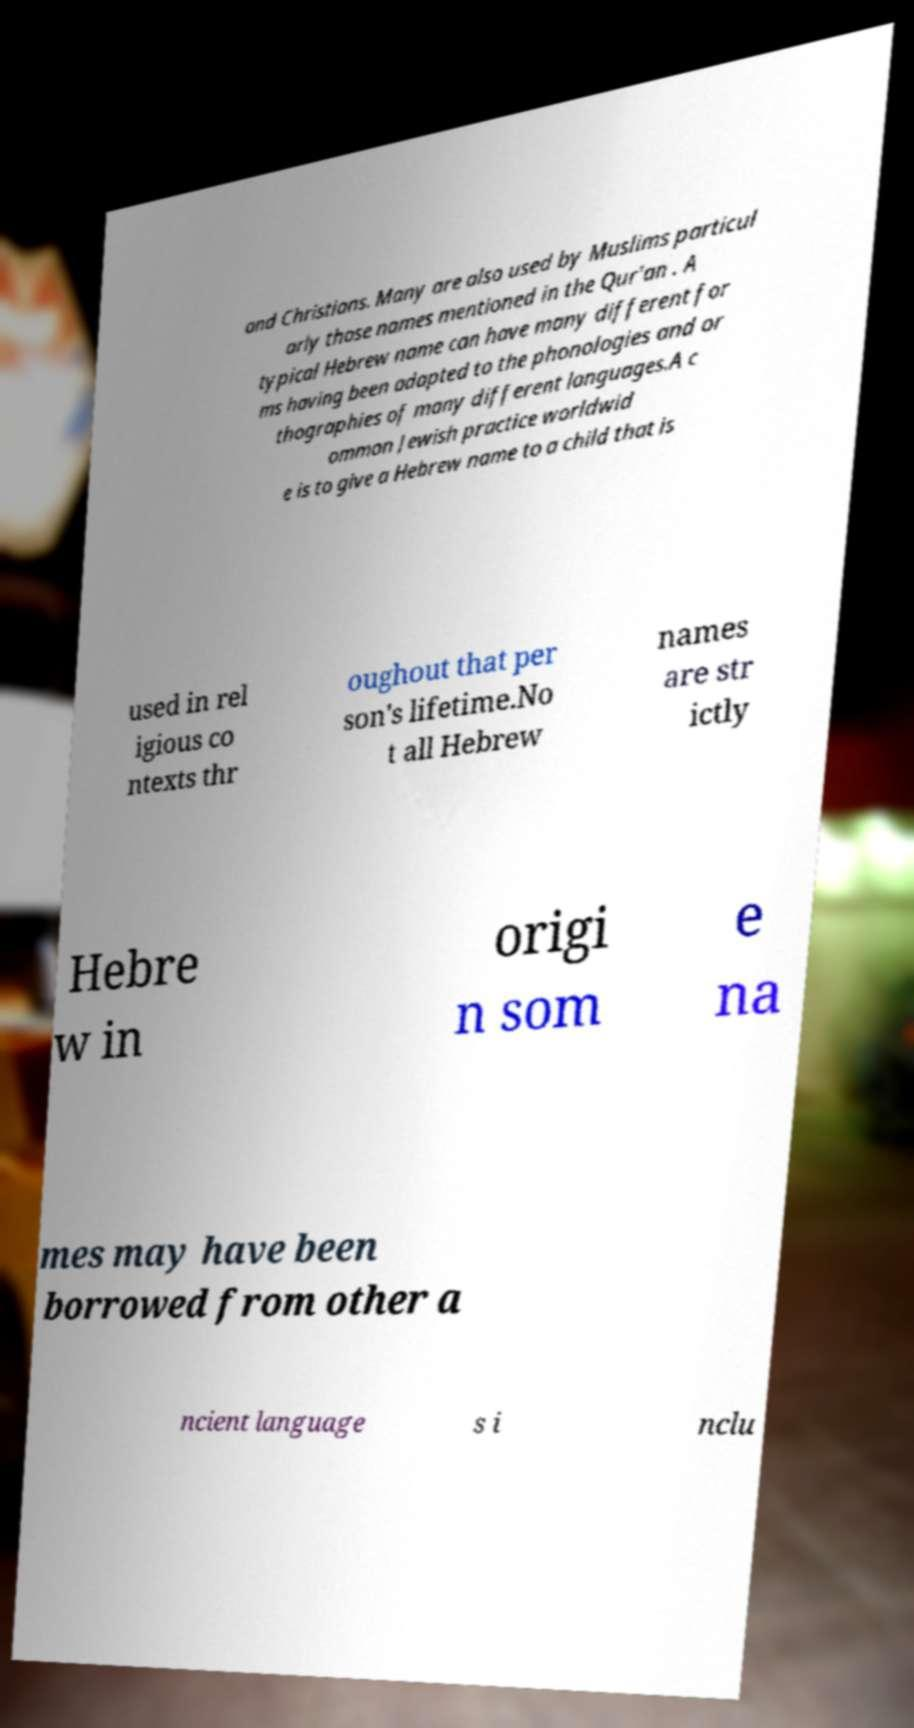Please read and relay the text visible in this image. What does it say? and Christians. Many are also used by Muslims particul arly those names mentioned in the Qur'an . A typical Hebrew name can have many different for ms having been adapted to the phonologies and or thographies of many different languages.A c ommon Jewish practice worldwid e is to give a Hebrew name to a child that is used in rel igious co ntexts thr oughout that per son's lifetime.No t all Hebrew names are str ictly Hebre w in origi n som e na mes may have been borrowed from other a ncient language s i nclu 